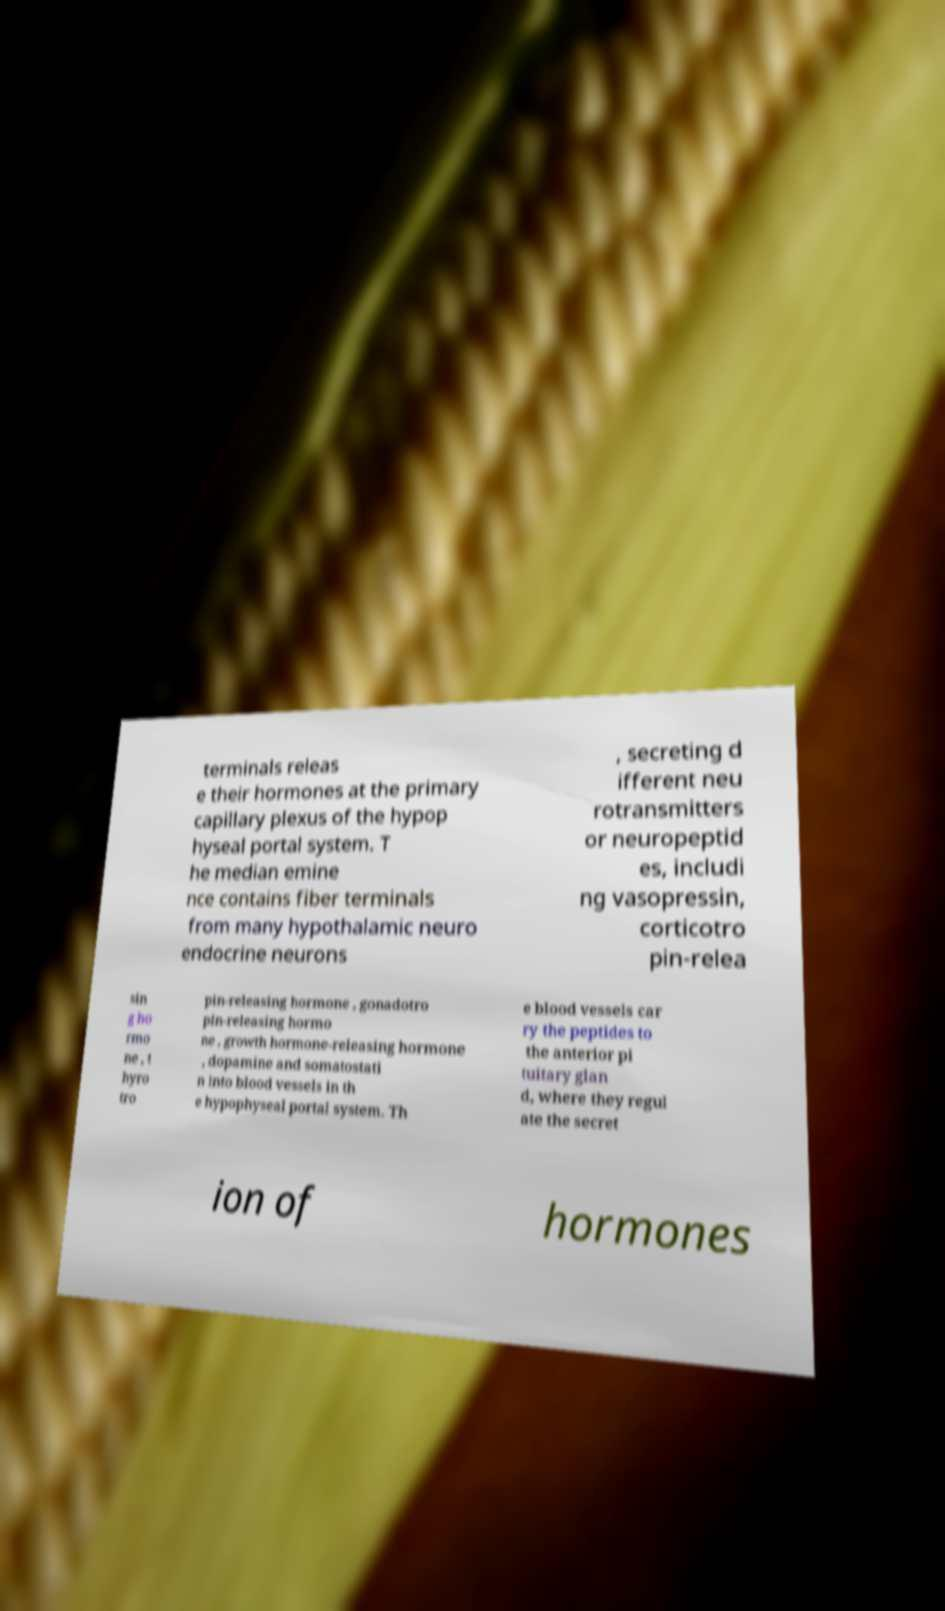I need the written content from this picture converted into text. Can you do that? terminals releas e their hormones at the primary capillary plexus of the hypop hyseal portal system. T he median emine nce contains fiber terminals from many hypothalamic neuro endocrine neurons , secreting d ifferent neu rotransmitters or neuropeptid es, includi ng vasopressin, corticotro pin-relea sin g ho rmo ne , t hyro tro pin-releasing hormone , gonadotro pin-releasing hormo ne , growth hormone-releasing hormone , dopamine and somatostati n into blood vessels in th e hypophyseal portal system. Th e blood vessels car ry the peptides to the anterior pi tuitary glan d, where they regul ate the secret ion of hormones 